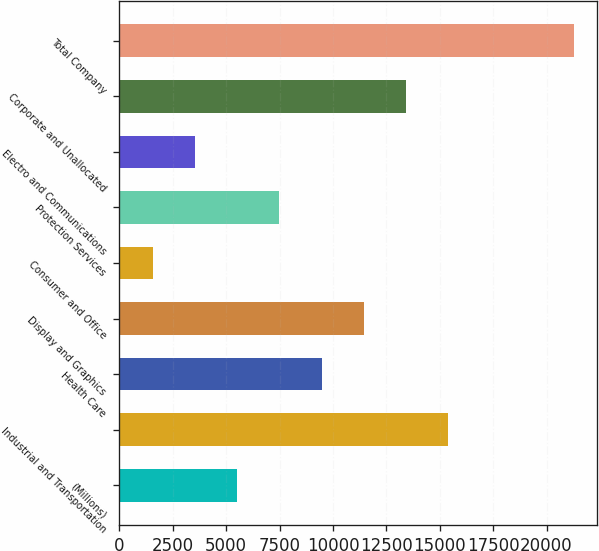Convert chart. <chart><loc_0><loc_0><loc_500><loc_500><bar_chart><fcel>(Millions)<fcel>Industrial and Transportation<fcel>Health Care<fcel>Display and Graphics<fcel>Consumer and Office<fcel>Protection Services<fcel>Electro and Communications<fcel>Corporate and Unallocated<fcel>Total Company<nl><fcel>5520.4<fcel>15378.9<fcel>9463.8<fcel>11435.5<fcel>1577<fcel>7492.1<fcel>3548.7<fcel>13407.2<fcel>21294<nl></chart> 